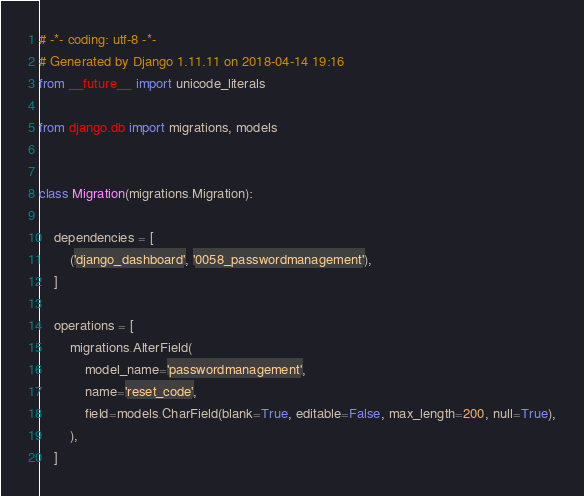<code> <loc_0><loc_0><loc_500><loc_500><_Python_># -*- coding: utf-8 -*-
# Generated by Django 1.11.11 on 2018-04-14 19:16
from __future__ import unicode_literals

from django.db import migrations, models


class Migration(migrations.Migration):

    dependencies = [
        ('django_dashboard', '0058_passwordmanagement'),
    ]

    operations = [
        migrations.AlterField(
            model_name='passwordmanagement',
            name='reset_code',
            field=models.CharField(blank=True, editable=False, max_length=200, null=True),
        ),
    ]
</code> 